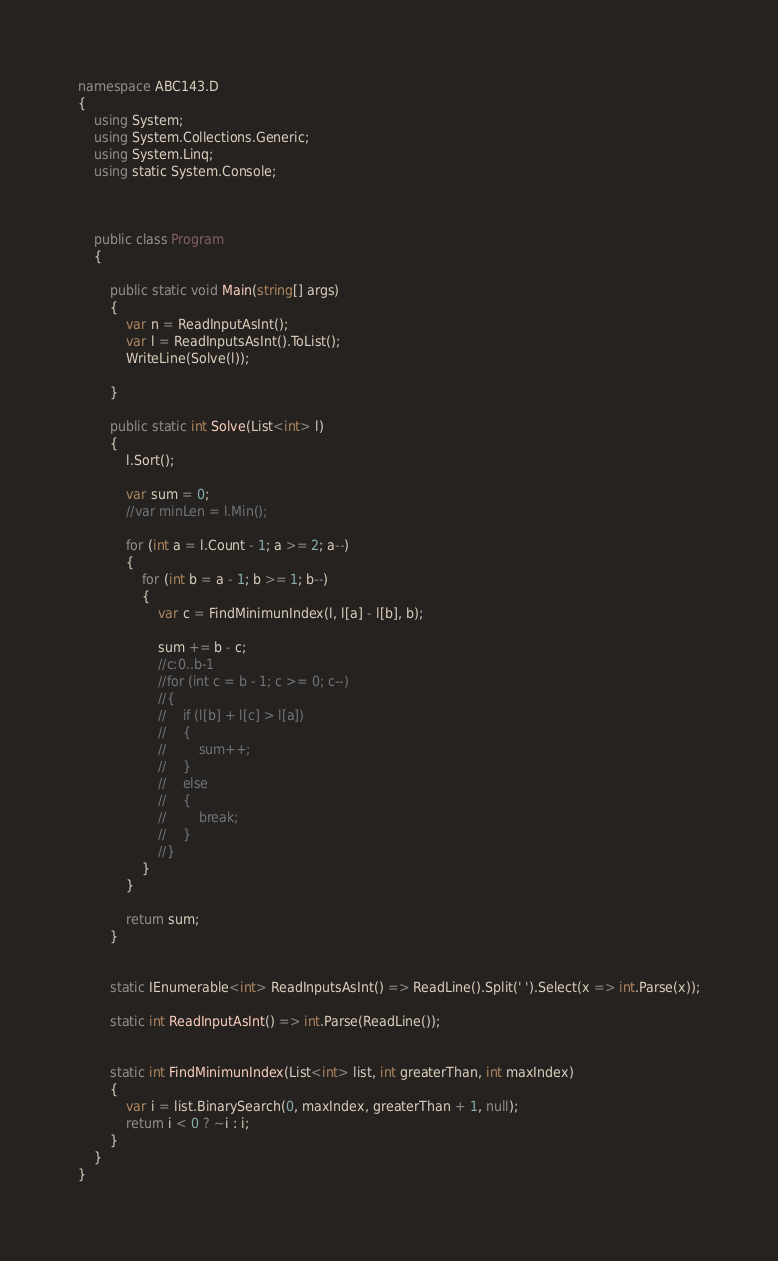<code> <loc_0><loc_0><loc_500><loc_500><_C#_>namespace ABC143.D
{
    using System;
    using System.Collections.Generic;
    using System.Linq;
    using static System.Console;



    public class Program
    {

        public static void Main(string[] args)
        {
            var n = ReadInputAsInt();
            var l = ReadInputsAsInt().ToList();
            WriteLine(Solve(l));

        }

        public static int Solve(List<int> l)
        {
            l.Sort();

            var sum = 0;
            //var minLen = l.Min();

            for (int a = l.Count - 1; a >= 2; a--)
            {
                for (int b = a - 1; b >= 1; b--)
                {
                    var c = FindMinimunIndex(l, l[a] - l[b], b);

                    sum += b - c;
                    //c:0..b-1
                    //for (int c = b - 1; c >= 0; c--)
                    //{
                    //    if (l[b] + l[c] > l[a])
                    //    {
                    //        sum++;
                    //    }
                    //    else
                    //    {
                    //        break;
                    //    }
                    //}
                }
            }

            return sum;
        }


        static IEnumerable<int> ReadInputsAsInt() => ReadLine().Split(' ').Select(x => int.Parse(x));

        static int ReadInputAsInt() => int.Parse(ReadLine());


        static int FindMinimunIndex(List<int> list, int greaterThan, int maxIndex)
        {
            var i = list.BinarySearch(0, maxIndex, greaterThan + 1, null);
            return i < 0 ? ~i : i;
        }
    }
}
</code> 